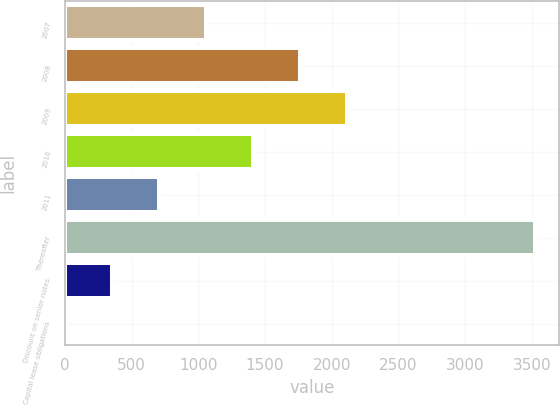Convert chart. <chart><loc_0><loc_0><loc_500><loc_500><bar_chart><fcel>2007<fcel>2008<fcel>2009<fcel>2010<fcel>2011<fcel>Thereafter<fcel>Discount on senior notes<fcel>Capital lease obligations<nl><fcel>1059.9<fcel>1764.5<fcel>2116.8<fcel>1412.2<fcel>707.6<fcel>3526<fcel>355.3<fcel>3<nl></chart> 